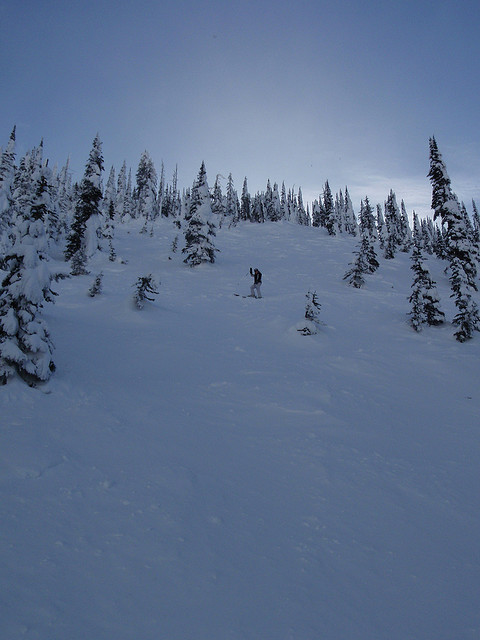Is there a person skiing or snowboarding in the image? In the image, there is a person actively snowboarding down a steep, snow-packed slope. This individual appears dressed in winter sports gear, navigating skillfully through the pristine white snow. 